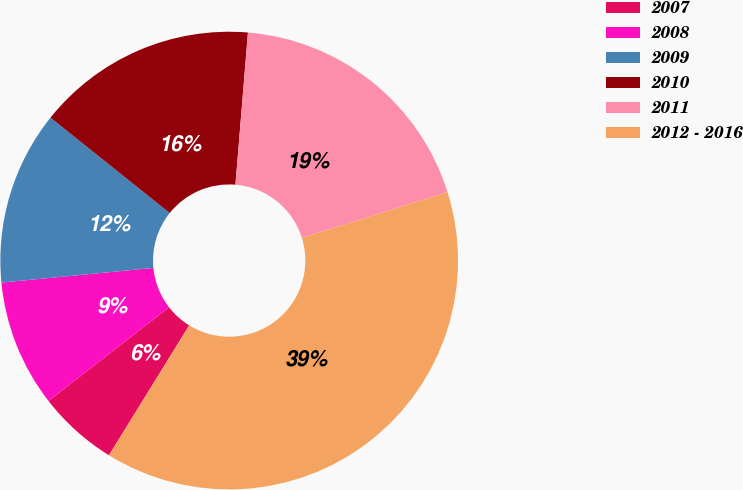<chart> <loc_0><loc_0><loc_500><loc_500><pie_chart><fcel>2007<fcel>2008<fcel>2009<fcel>2010<fcel>2011<fcel>2012 - 2016<nl><fcel>5.68%<fcel>8.98%<fcel>12.27%<fcel>15.57%<fcel>18.86%<fcel>38.63%<nl></chart> 